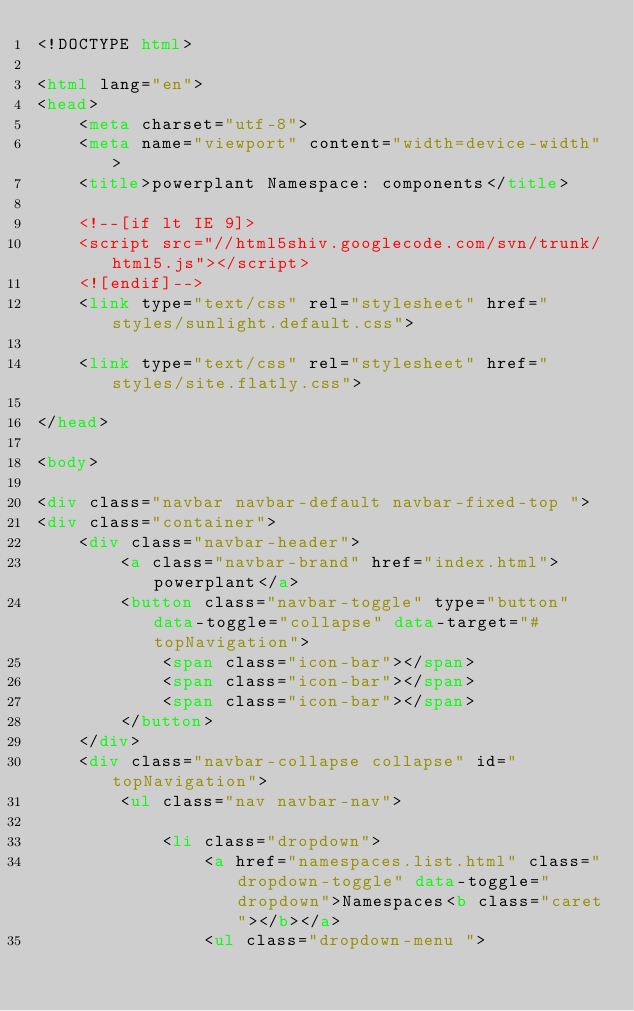Convert code to text. <code><loc_0><loc_0><loc_500><loc_500><_HTML_><!DOCTYPE html>

<html lang="en">
<head>
	<meta charset="utf-8">
	<meta name="viewport" content="width=device-width">
	<title>powerplant Namespace: components</title>

	<!--[if lt IE 9]>
	<script src="//html5shiv.googlecode.com/svn/trunk/html5.js"></script>
	<![endif]-->
	<link type="text/css" rel="stylesheet" href="styles/sunlight.default.css">

	<link type="text/css" rel="stylesheet" href="styles/site.flatly.css">

</head>

<body>

<div class="navbar navbar-default navbar-fixed-top ">
<div class="container">
	<div class="navbar-header">
		<a class="navbar-brand" href="index.html">powerplant</a>
		<button class="navbar-toggle" type="button" data-toggle="collapse" data-target="#topNavigation">
			<span class="icon-bar"></span>
			<span class="icon-bar"></span>
			<span class="icon-bar"></span>
        </button>
	</div>
	<div class="navbar-collapse collapse" id="topNavigation">
		<ul class="nav navbar-nav">
			
			<li class="dropdown">
				<a href="namespaces.list.html" class="dropdown-toggle" data-toggle="dropdown">Namespaces<b class="caret"></b></a>
				<ul class="dropdown-menu "></code> 